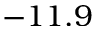<formula> <loc_0><loc_0><loc_500><loc_500>- 1 1 . 9</formula> 